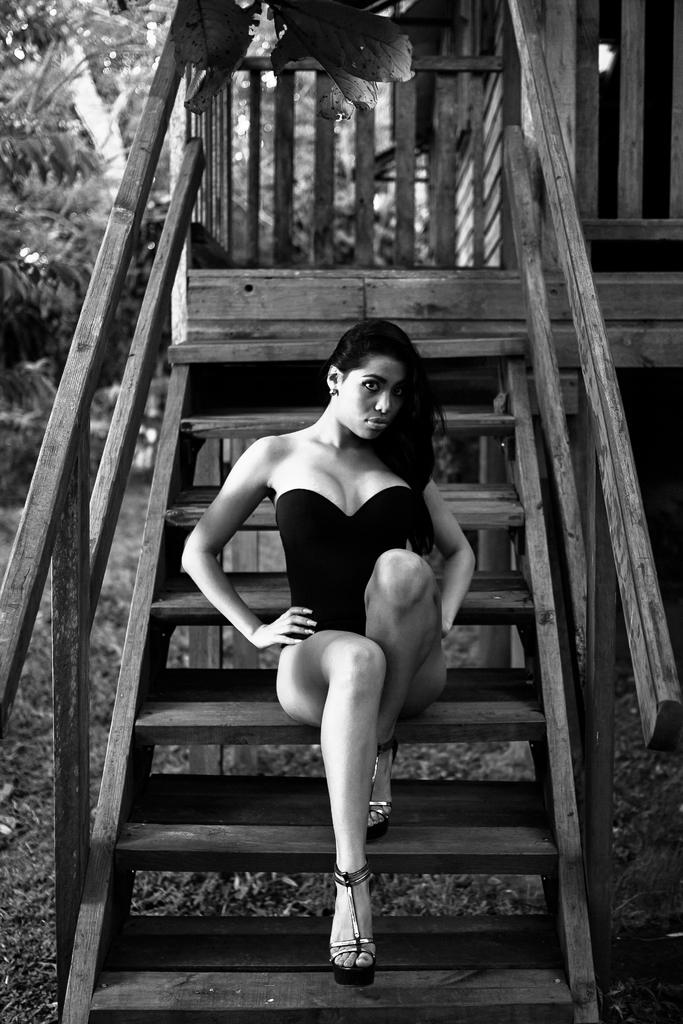What is the color scheme of the image? The image is black and white. What is the woman in the image doing? The woman is sitting on the stairs. What can be seen in the background of the image? There are trees in the background of the image. What type of material is the railing in the image made of? The railing in the image is made of wood. What type of pie is the woman holding in the image? There is no pie present in the image; the woman is sitting on the stairs with no visible objects in her hands. 